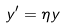<formula> <loc_0><loc_0><loc_500><loc_500>y ^ { \prime } = \eta y</formula> 